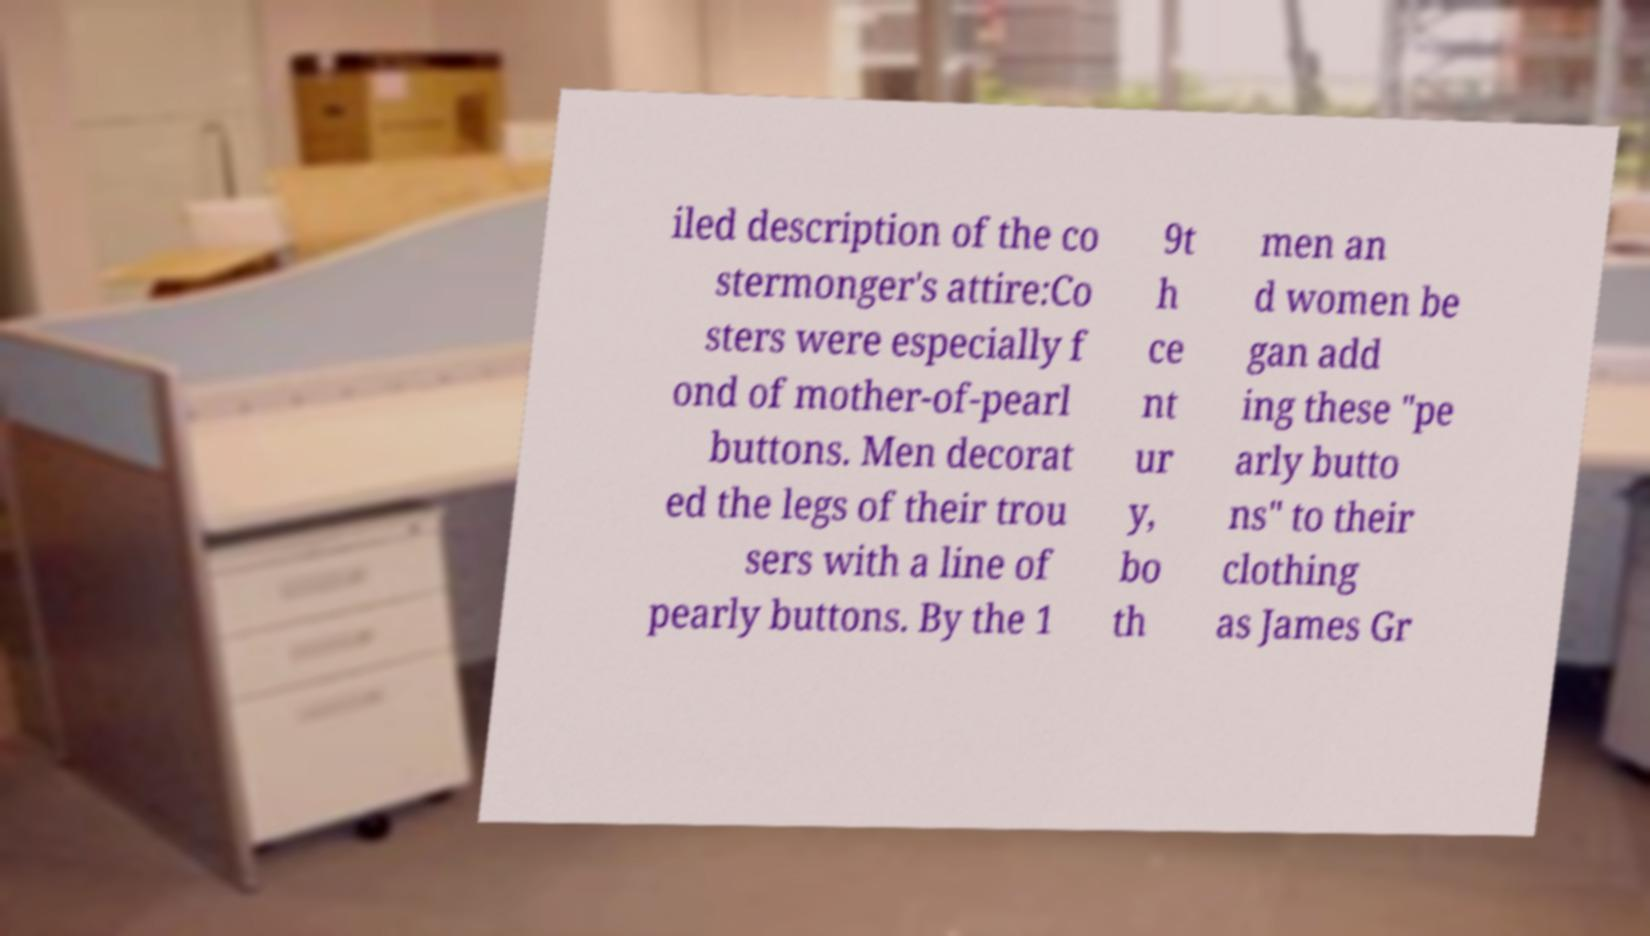Please read and relay the text visible in this image. What does it say? iled description of the co stermonger's attire:Co sters were especially f ond of mother-of-pearl buttons. Men decorat ed the legs of their trou sers with a line of pearly buttons. By the 1 9t h ce nt ur y, bo th men an d women be gan add ing these "pe arly butto ns" to their clothing as James Gr 